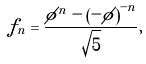Convert formula to latex. <formula><loc_0><loc_0><loc_500><loc_500>f _ { n } = \frac { \phi ^ { n } - \left ( - \phi \right ) ^ { - n } } { \sqrt { 5 } } ,</formula> 